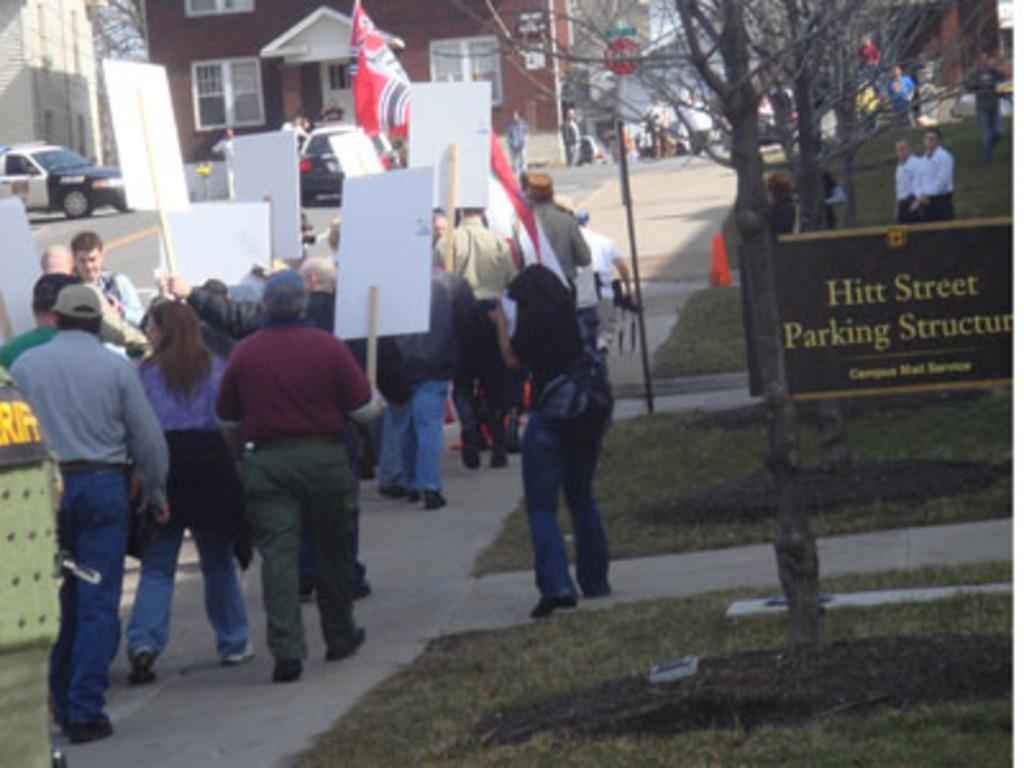What is the main object in the foreground of the image? There is a notice board in the foreground of the image. What is the notice board placed on? The notice board is on grassland. What are the people in the image holding? The people in the image are holding posters. What can be seen in the background of the image? There are trees, houses, and vehicles in the background of the image. What type of feast is being prepared in the image? There is no indication of a feast being prepared in the image. Can you tell me how many bombs are visible in the image? There are no bombs present in the image. 